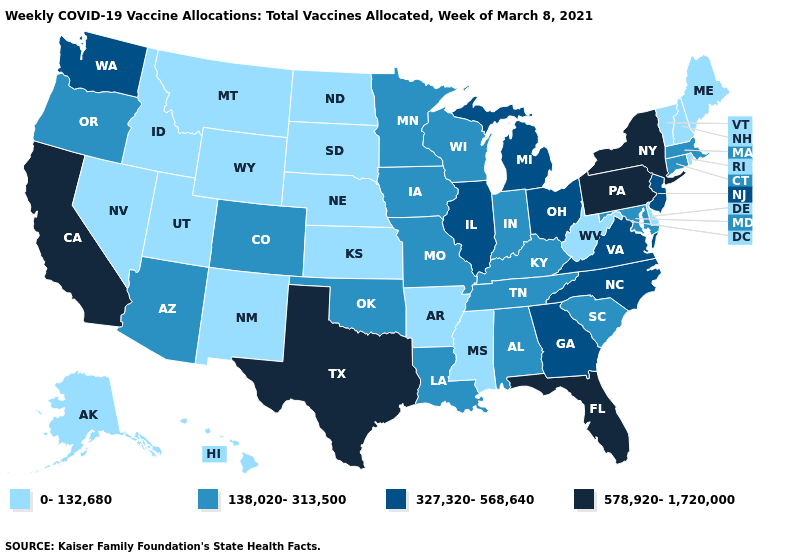Does Ohio have the same value as Michigan?
Answer briefly. Yes. What is the lowest value in the MidWest?
Be succinct. 0-132,680. Does the map have missing data?
Answer briefly. No. Among the states that border Massachusetts , which have the highest value?
Quick response, please. New York. What is the value of Nebraska?
Give a very brief answer. 0-132,680. What is the value of Ohio?
Be succinct. 327,320-568,640. Name the states that have a value in the range 138,020-313,500?
Be succinct. Alabama, Arizona, Colorado, Connecticut, Indiana, Iowa, Kentucky, Louisiana, Maryland, Massachusetts, Minnesota, Missouri, Oklahoma, Oregon, South Carolina, Tennessee, Wisconsin. What is the value of Utah?
Give a very brief answer. 0-132,680. What is the highest value in the South ?
Give a very brief answer. 578,920-1,720,000. Name the states that have a value in the range 0-132,680?
Short answer required. Alaska, Arkansas, Delaware, Hawaii, Idaho, Kansas, Maine, Mississippi, Montana, Nebraska, Nevada, New Hampshire, New Mexico, North Dakota, Rhode Island, South Dakota, Utah, Vermont, West Virginia, Wyoming. What is the highest value in states that border Ohio?
Answer briefly. 578,920-1,720,000. What is the value of Maryland?
Short answer required. 138,020-313,500. Which states have the lowest value in the USA?
Concise answer only. Alaska, Arkansas, Delaware, Hawaii, Idaho, Kansas, Maine, Mississippi, Montana, Nebraska, Nevada, New Hampshire, New Mexico, North Dakota, Rhode Island, South Dakota, Utah, Vermont, West Virginia, Wyoming. What is the value of North Carolina?
Concise answer only. 327,320-568,640. What is the value of Hawaii?
Concise answer only. 0-132,680. 